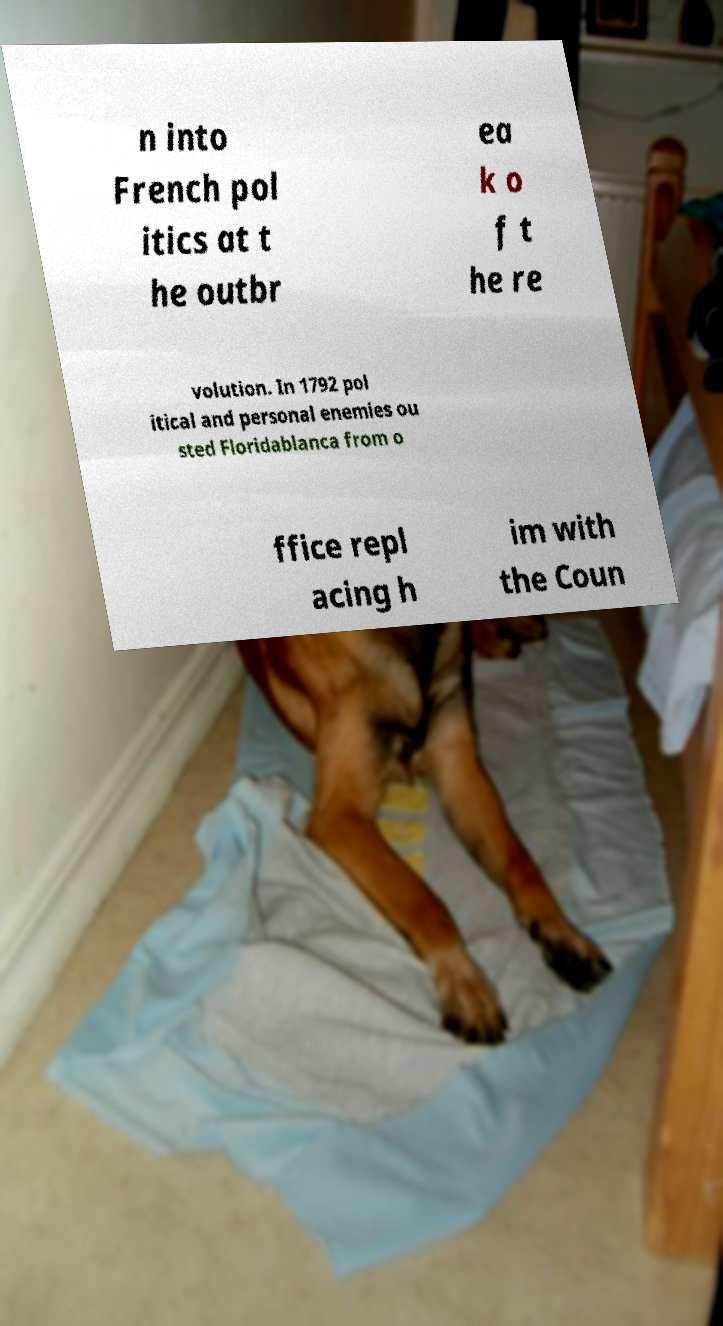There's text embedded in this image that I need extracted. Can you transcribe it verbatim? n into French pol itics at t he outbr ea k o f t he re volution. In 1792 pol itical and personal enemies ou sted Floridablanca from o ffice repl acing h im with the Coun 